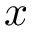Convert formula to latex. <formula><loc_0><loc_0><loc_500><loc_500>x</formula> 